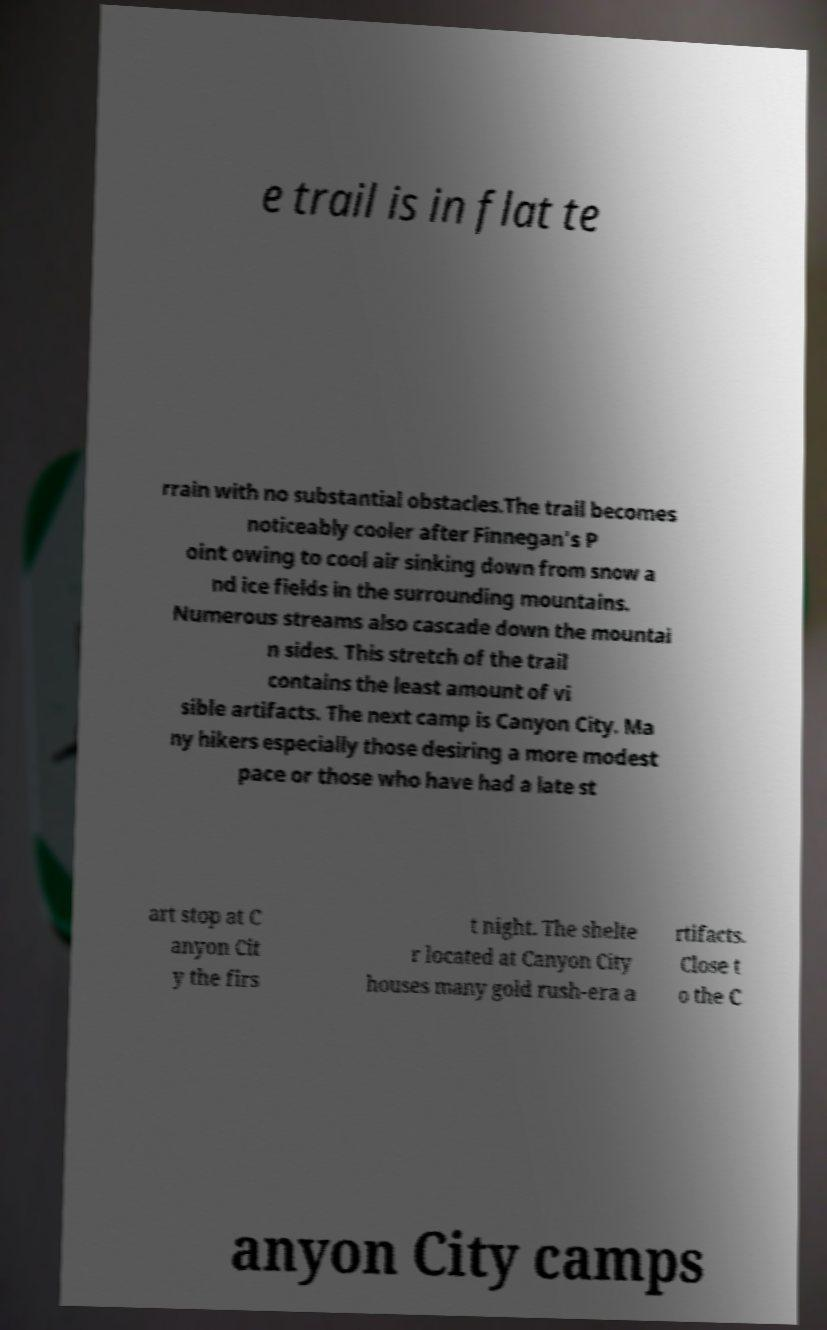There's text embedded in this image that I need extracted. Can you transcribe it verbatim? e trail is in flat te rrain with no substantial obstacles.The trail becomes noticeably cooler after Finnegan's P oint owing to cool air sinking down from snow a nd ice fields in the surrounding mountains. Numerous streams also cascade down the mountai n sides. This stretch of the trail contains the least amount of vi sible artifacts. The next camp is Canyon City. Ma ny hikers especially those desiring a more modest pace or those who have had a late st art stop at C anyon Cit y the firs t night. The shelte r located at Canyon City houses many gold rush-era a rtifacts. Close t o the C anyon City camps 